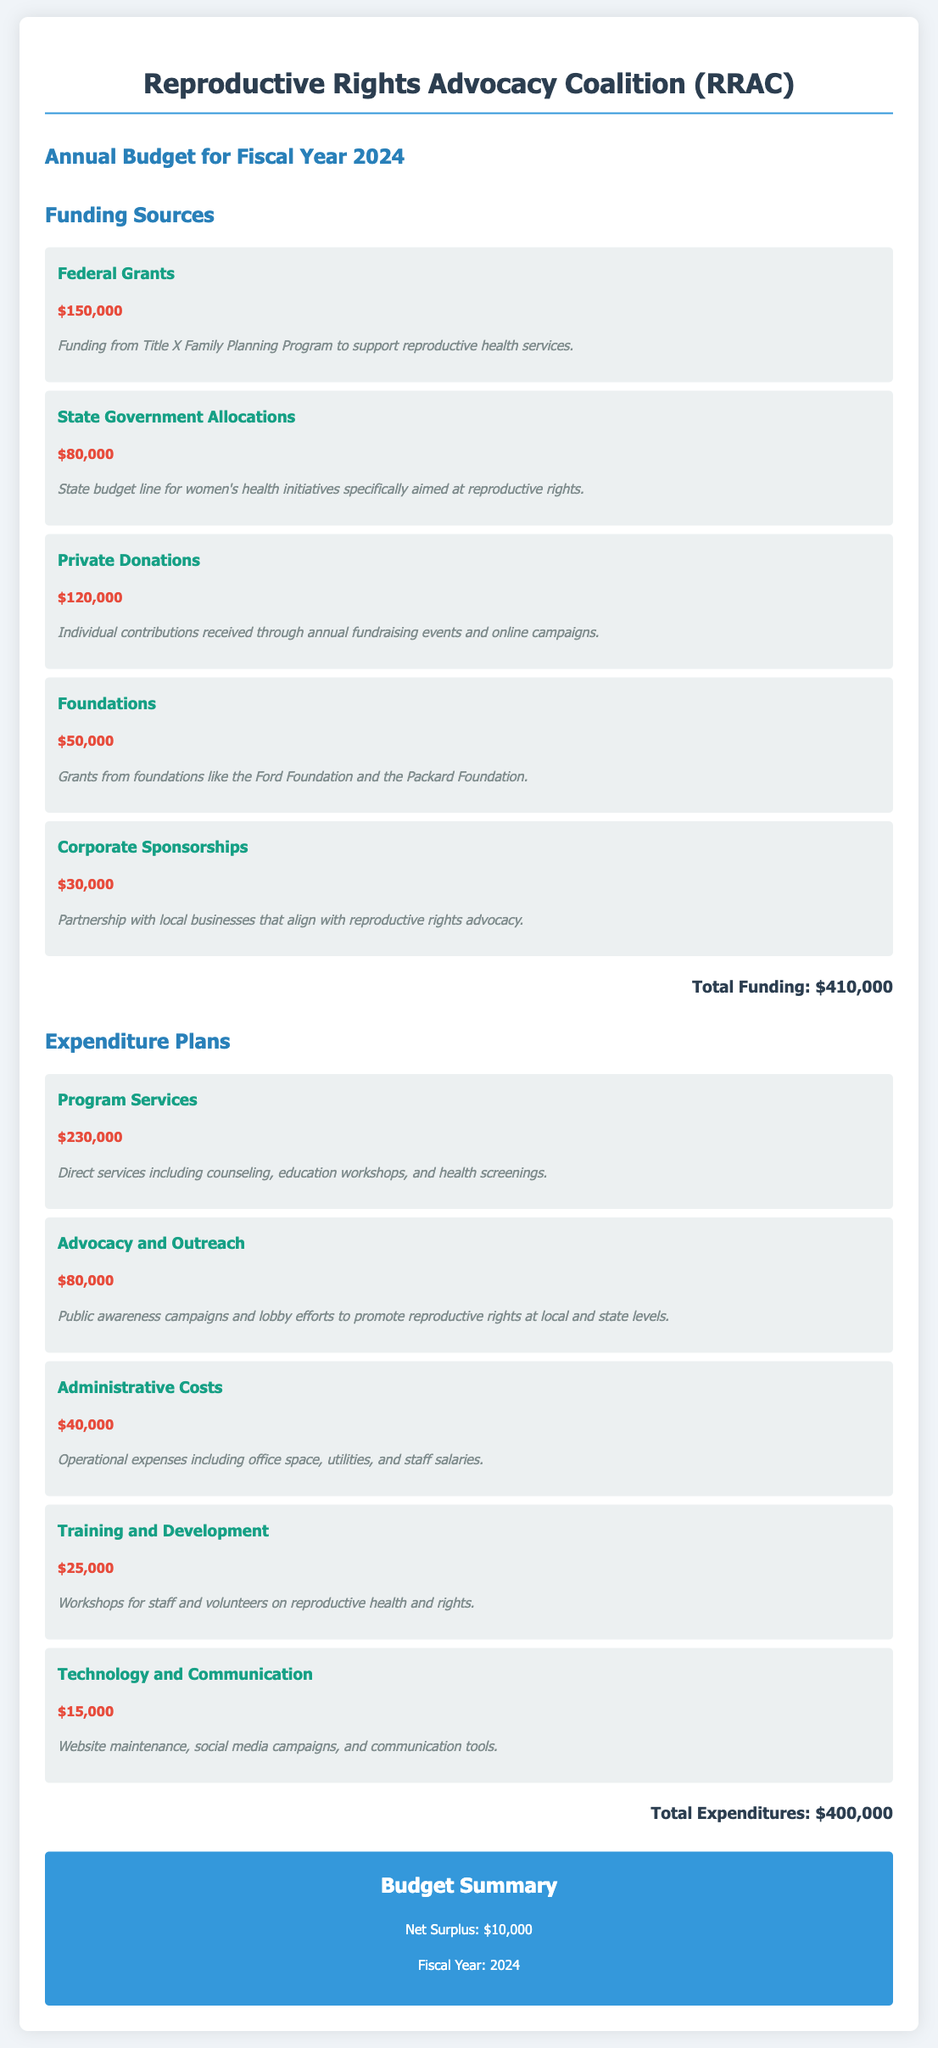What is the total funding? The total funding is the sum of all funding sources listed in the document, which is $150,000 + $80,000 + $120,000 + $50,000 + $30,000 = $410,000.
Answer: $410,000 What is the amount allocated for Program Services? The Program Services expenditure is specified in the document as $230,000.
Answer: $230,000 How much is received from Private Donations? The document indicates that Private Donations contribute $120,000 to the funding sources.
Answer: $120,000 What is the purpose of the Advocacy and Outreach funding? The Advocacy and Outreach funding is aimed at public awareness campaigns and lobbying for reproductive rights.
Answer: Public awareness campaigns and lobby efforts What is the net surplus for the fiscal year? The net surplus is calculated as the total funding minus total expenditures, which results in $10,000 after considering both figures.
Answer: $10,000 What is the total expenditure for Administrative Costs? The document states that the total expenditure for Administrative Costs is $40,000.
Answer: $40,000 Which foundation is mentioned as a funding source? The document lists the Ford Foundation as one of the foundations providing financial support.
Answer: Ford Foundation How much is allocated for Technology and Communication? The expenditure for Technology and Communication is specified in the document as $15,000.
Answer: $15,000 What fiscal year is the budget prepared for? The document indicates that the budget is prepared for the fiscal year 2024.
Answer: 2024 